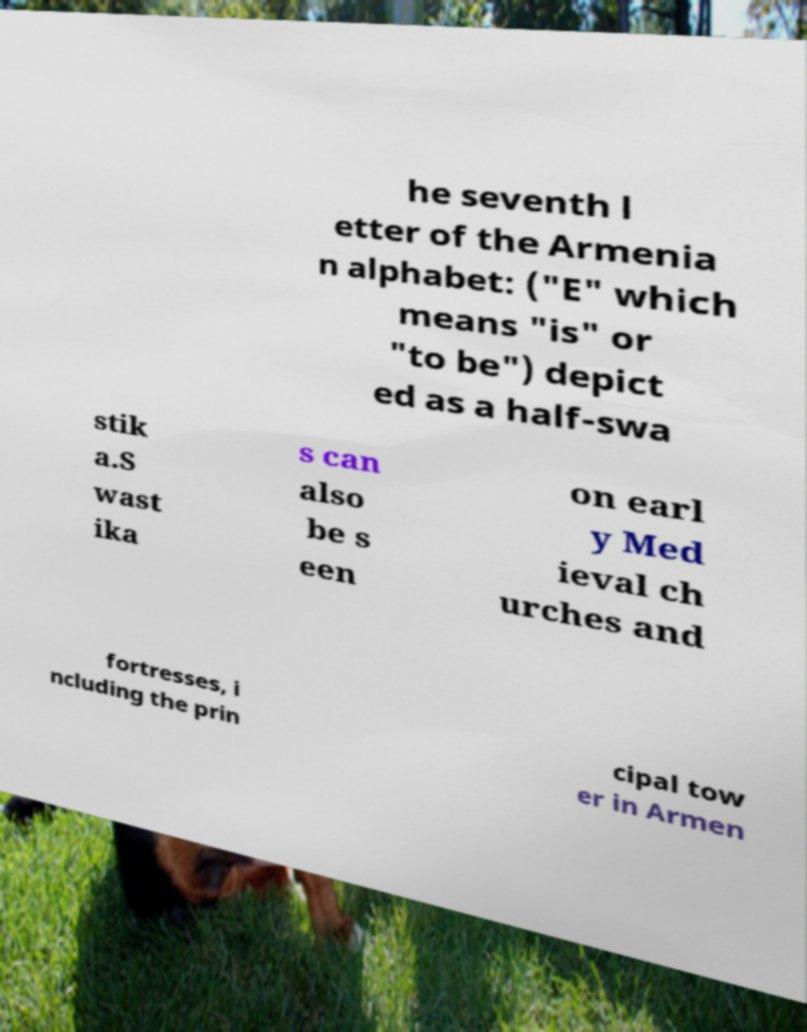For documentation purposes, I need the text within this image transcribed. Could you provide that? he seventh l etter of the Armenia n alphabet: ("E" which means "is" or "to be") depict ed as a half-swa stik a.S wast ika s can also be s een on earl y Med ieval ch urches and fortresses, i ncluding the prin cipal tow er in Armen 